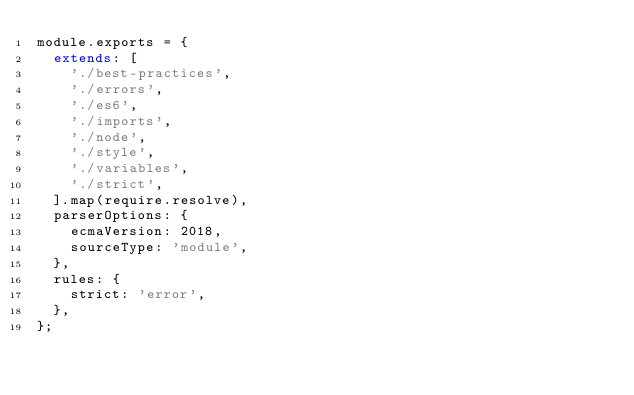<code> <loc_0><loc_0><loc_500><loc_500><_JavaScript_>module.exports = {
  extends: [
		'./best-practices',
		'./errors',
		'./es6',
		'./imports',
		'./node',
		'./style',
		'./variables',
		'./strict',
  ].map(require.resolve),
  parserOptions: {
    ecmaVersion: 2018,
    sourceType: 'module',
  },
  rules: {
    strict: 'error',
  },
};</code> 